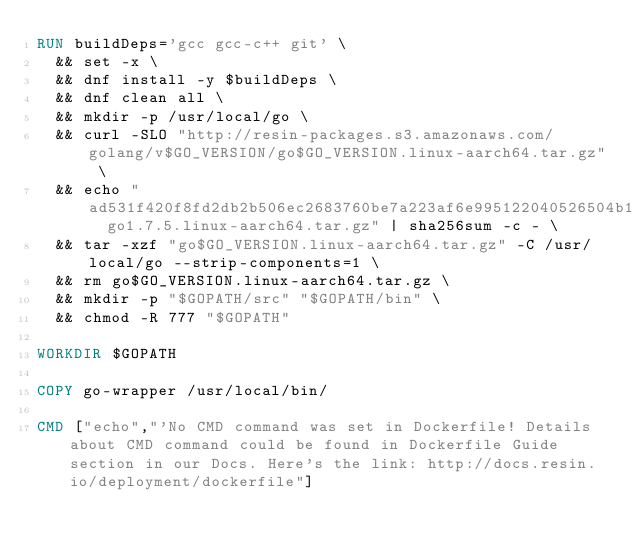Convert code to text. <code><loc_0><loc_0><loc_500><loc_500><_Dockerfile_>RUN buildDeps='gcc gcc-c++ git' \
	&& set -x \
	&& dnf install -y $buildDeps \
	&& dnf clean all \
	&& mkdir -p /usr/local/go \
	&& curl -SLO "http://resin-packages.s3.amazonaws.com/golang/v$GO_VERSION/go$GO_VERSION.linux-aarch64.tar.gz" \
	&& echo "ad531f420f8fd2db2b506ec2683760be7a223af6e995122040526504b11a736c  go1.7.5.linux-aarch64.tar.gz" | sha256sum -c - \
	&& tar -xzf "go$GO_VERSION.linux-aarch64.tar.gz" -C /usr/local/go --strip-components=1 \
	&& rm go$GO_VERSION.linux-aarch64.tar.gz \
	&& mkdir -p "$GOPATH/src" "$GOPATH/bin" \
	&& chmod -R 777 "$GOPATH"

WORKDIR $GOPATH

COPY go-wrapper /usr/local/bin/

CMD ["echo","'No CMD command was set in Dockerfile! Details about CMD command could be found in Dockerfile Guide section in our Docs. Here's the link: http://docs.resin.io/deployment/dockerfile"]
</code> 